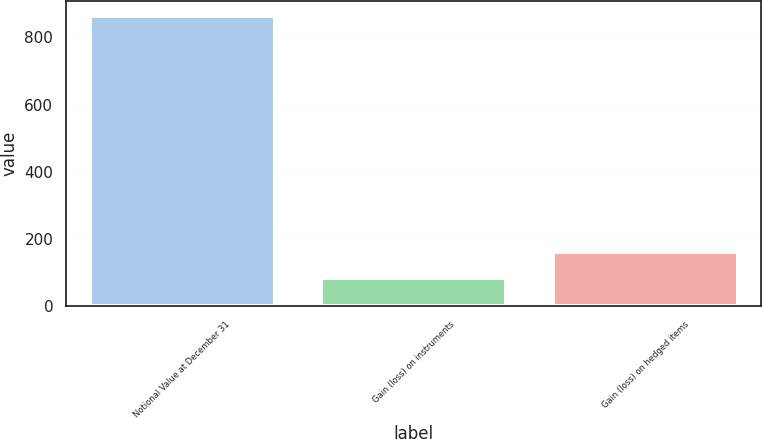Convert chart to OTSL. <chart><loc_0><loc_0><loc_500><loc_500><bar_chart><fcel>Notional Value at December 31<fcel>Gain (loss) on instruments<fcel>Gain (loss) on hedged items<nl><fcel>864<fcel>84<fcel>162<nl></chart> 